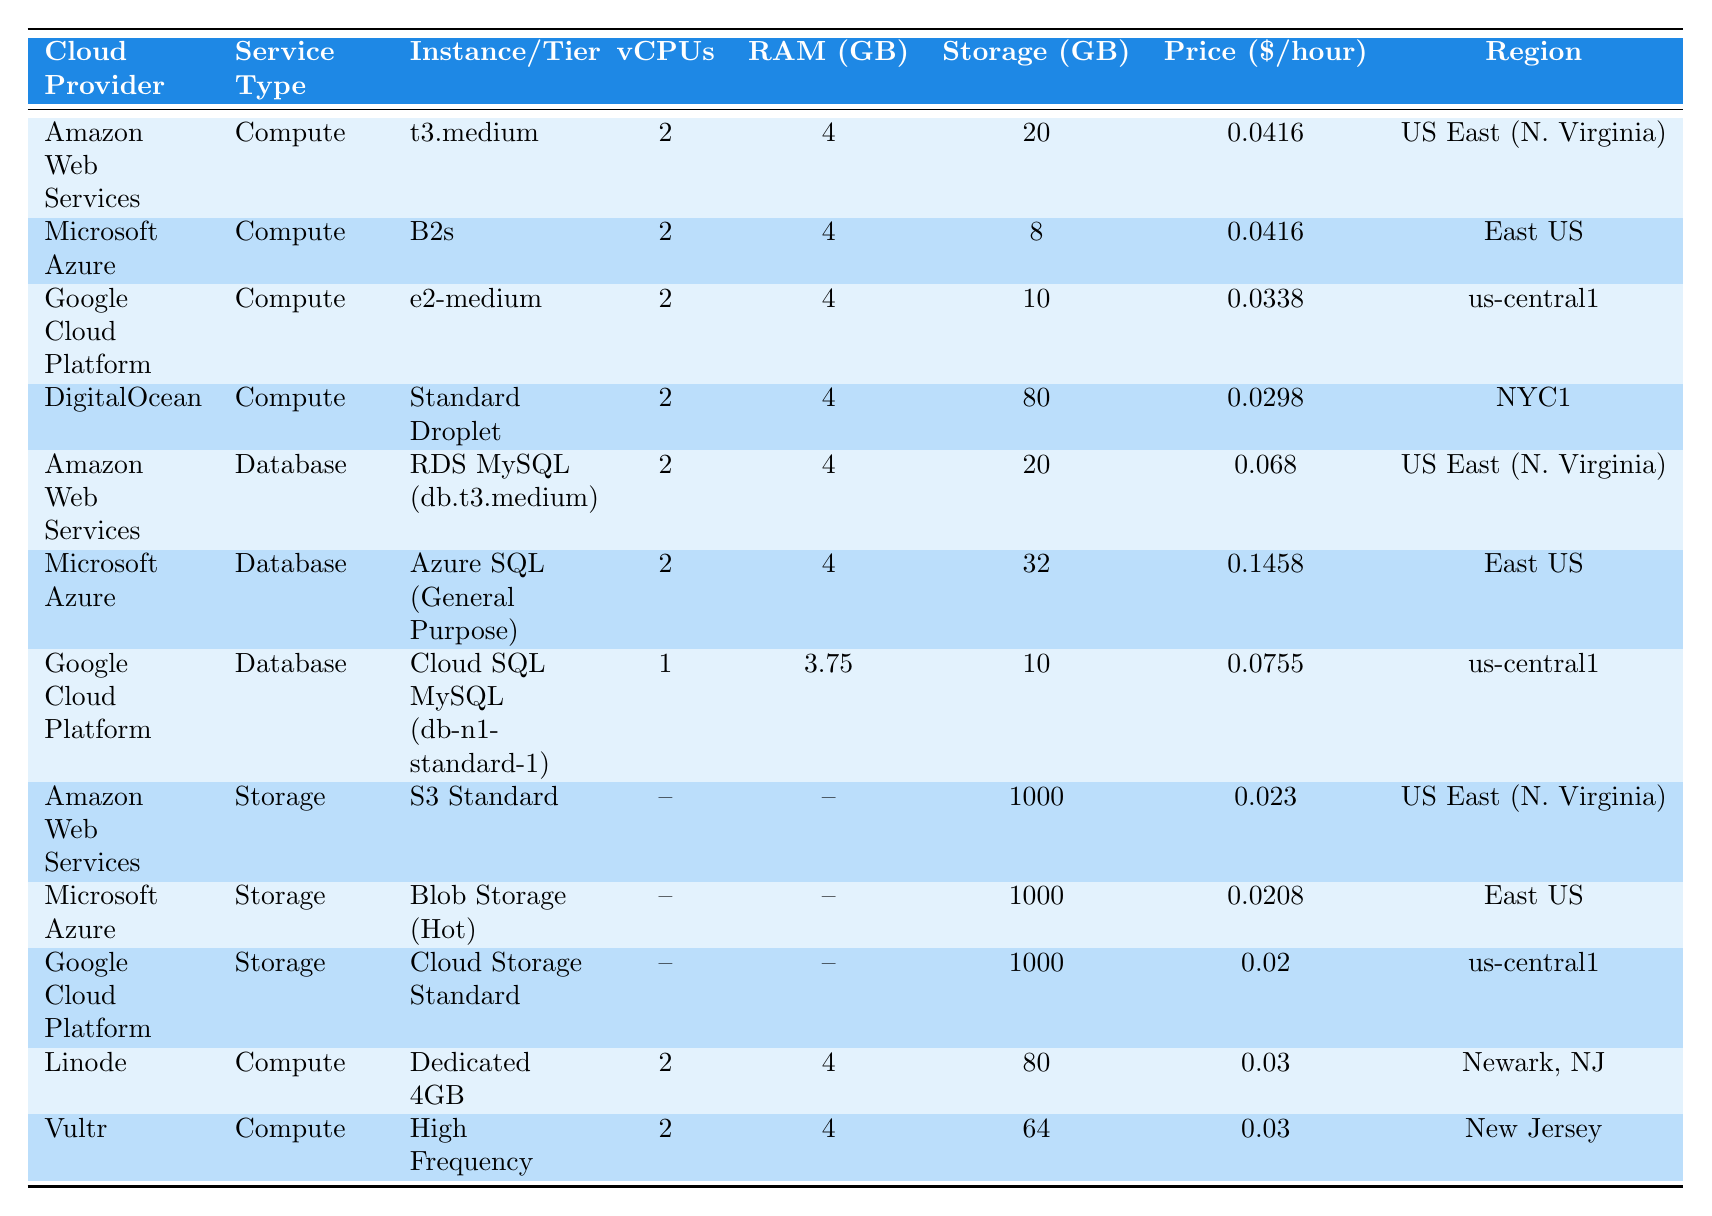What is the price per hour for the DigitalOcean Compute service? The table lists DigitalOcean's Compute service (Standard Droplet) with a price of $0.0298 per hour.
Answer: $0.0298 Which cloud provider has the lowest price for storage services? The storage services' prices for the three providers are: Amazon Web Services at $0.023, Microsoft Azure at $0.0208, and Google Cloud Platform at $0.02. The lowest price is from Google Cloud Platform.
Answer: Google Cloud Platform How much RAM does the Google Cloud Platform Compute instance have? The Google Cloud Platform Compute instance (e2-medium) has 4 GB of RAM, as stated in the table.
Answer: 4 GB What is the difference in price between Microsoft Azure's Database service and Amazon Web Services' Database service? Microsoft Azure's Database service costs $0.1458 per hour, while Amazon Web Services' Database service costs $0.068. The difference is $0.1458 - $0.068 = $0.0778.
Answer: $0.0778 Which provider offers a Compute service with the highest vCPUs? The table shows that all listed Compute services have 2 vCPUs except for Google Cloud Platform's Database service, which has 1 vCPU. Hence, they all provide the same vCPUs (2).
Answer: All have 2 vCPUs What is the average price per hour of the Compute services listed? The prices for the Compute services are: $0.0416 (AWS), $0.0416 (Azure), $0.0338 (GCP), $0.0298 (DigitalOcean), $0.03 (Linode), and $0.03 (Vultr). The average is (0.0416 + 0.0416 + 0.0338 + 0.0298 + 0.03 + 0.03) / 6 = $0.0347.
Answer: $0.0347 Is the storage price for Microsoft Azure higher than for Google Cloud Platform's storage? Microsoft Azure's storage price is $0.0208 and Google Cloud Platform's is $0.02. Since $0.0208 > $0.02, the statement is true.
Answer: Yes How many GB of storage does the Amazon Web Services (S3 Standard) offer? According to the table, Amazon Web Services' S3 Standard service offers 1000 GB of storage.
Answer: 1000 GB Which cloud provider has the highest price for its Database service? Microsoft Azure's Database service price is $0.1458, which is higher than the others listed: AWS ($0.068) and GCP ($0.0755). Therefore, Microsoft Azure has the highest price.
Answer: Microsoft Azure What is the total amount of storage across all listed Compute instances? The storage for listed Compute instances is 20 GB (AWS) + 8 GB (Azure) + 10 GB (GCP) + 80 GB (DigitalOcean) + 80 GB (Linode) + 64 GB (Vultr) = 262 GB total.
Answer: 262 GB Does any provider offer a Compute service with less than 30 GB of storage? Looking at the table, both DigitalOcean has 80 GB and Linode has 80 GB, while other Compute services have less. Therefore, none falls under 30 GB since they all have storage above that value.
Answer: No 